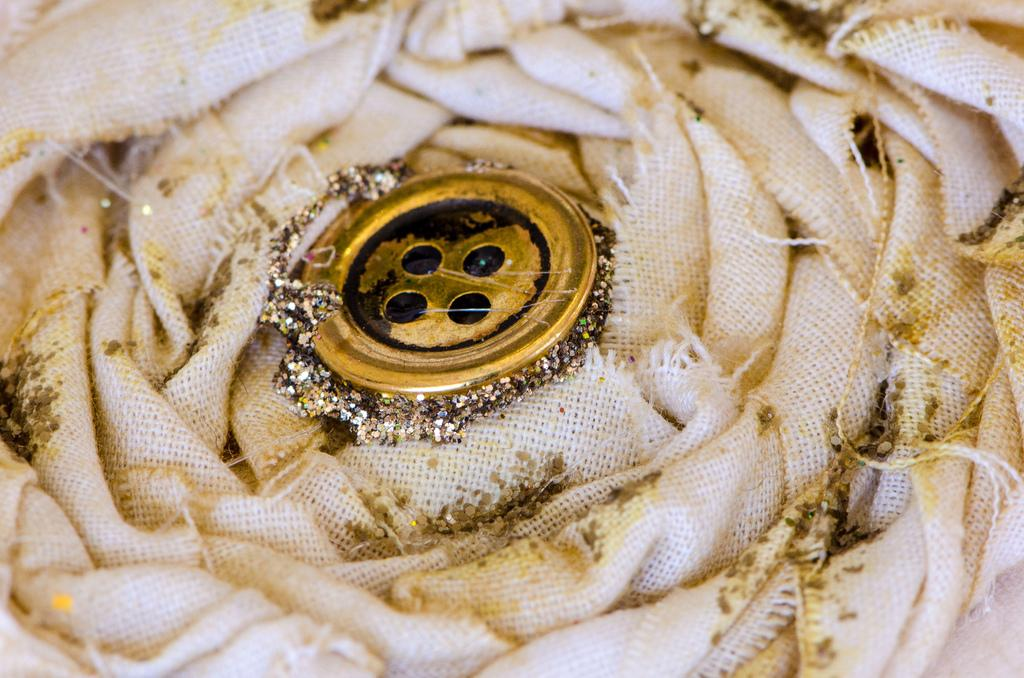What object with a small, round shape can be seen in the image? There is a button in the image. What additional feature is present on the button? The button has glitter on it. What type of material is at the bottom of the image? There is a cloth at the bottom of the image. Can you see a yak grazing on the cloth in the image? There is no yak present in the image; it only features a button with glitter and a cloth at the bottom. 